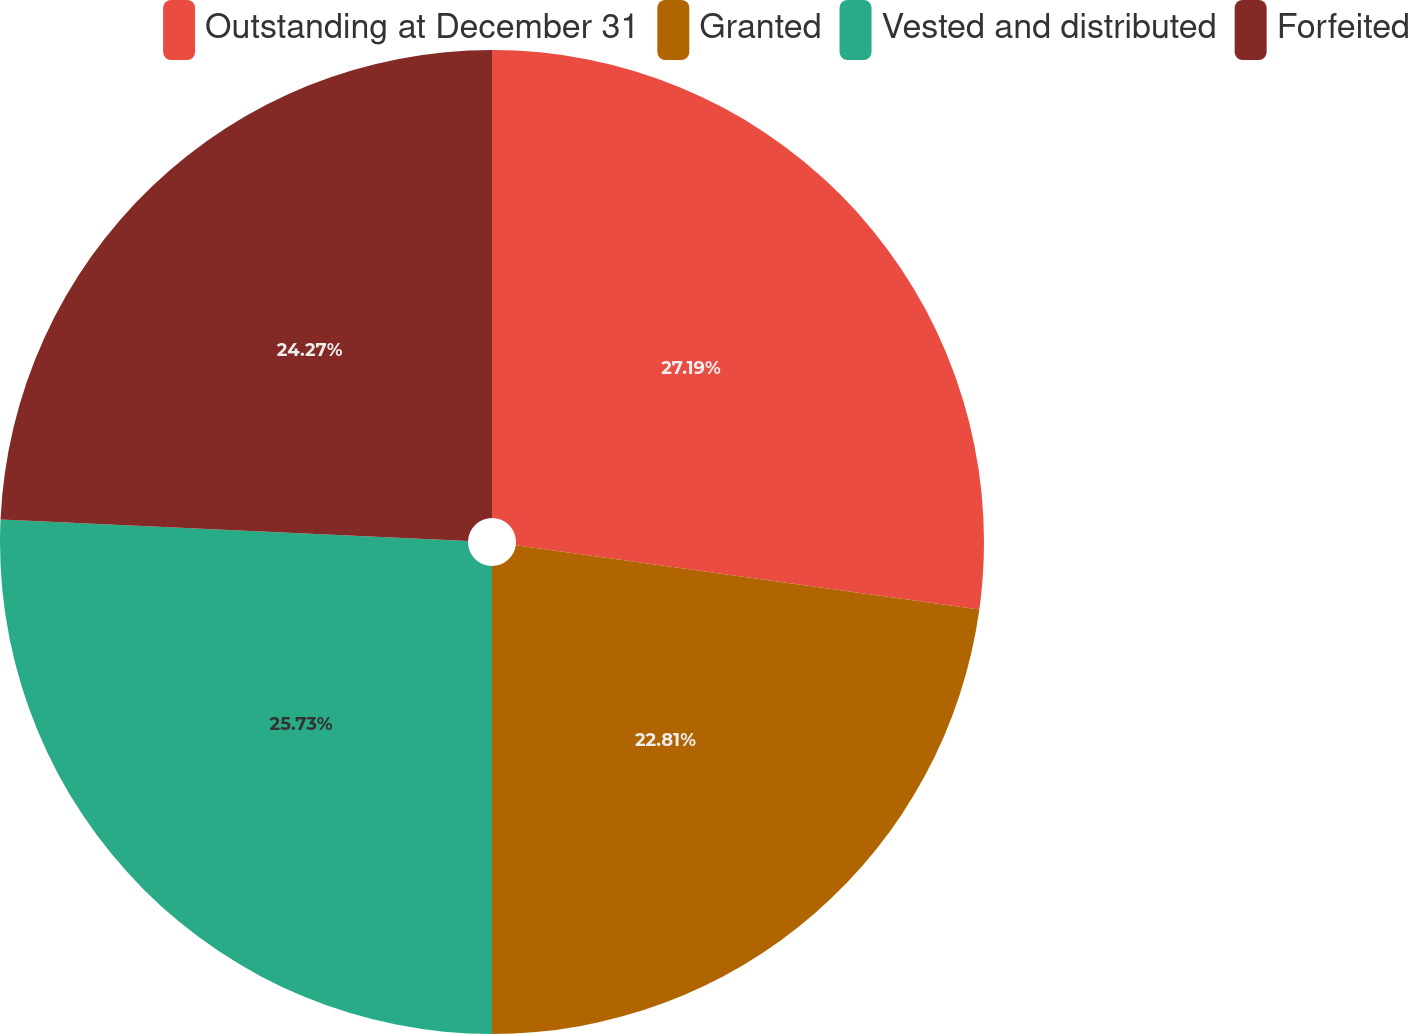Convert chart to OTSL. <chart><loc_0><loc_0><loc_500><loc_500><pie_chart><fcel>Outstanding at December 31<fcel>Granted<fcel>Vested and distributed<fcel>Forfeited<nl><fcel>27.19%<fcel>22.81%<fcel>25.73%<fcel>24.27%<nl></chart> 